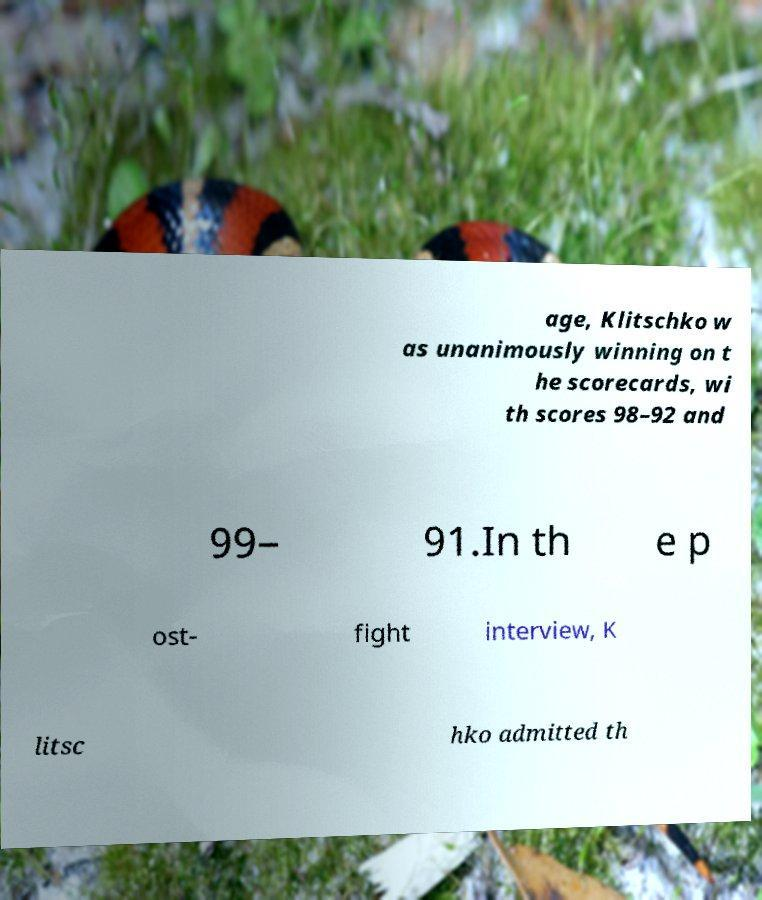Please read and relay the text visible in this image. What does it say? age, Klitschko w as unanimously winning on t he scorecards, wi th scores 98–92 and 99– 91.In th e p ost- fight interview, K litsc hko admitted th 